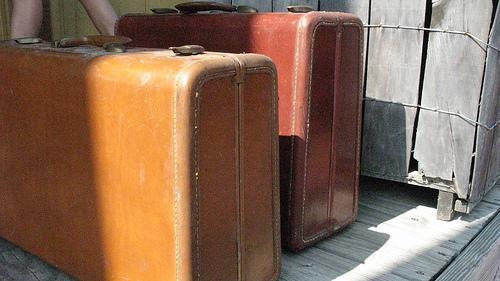How many suitcases are visible?
Give a very brief answer. 2. 